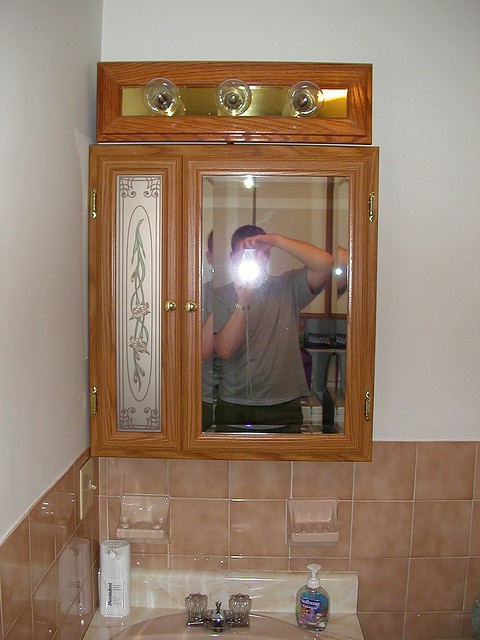Describe the objects in this image and their specific colors. I can see sink in darkgray and gray tones, people in darkgray, gray, and black tones, and bottle in darkgray, gray, and blue tones in this image. 